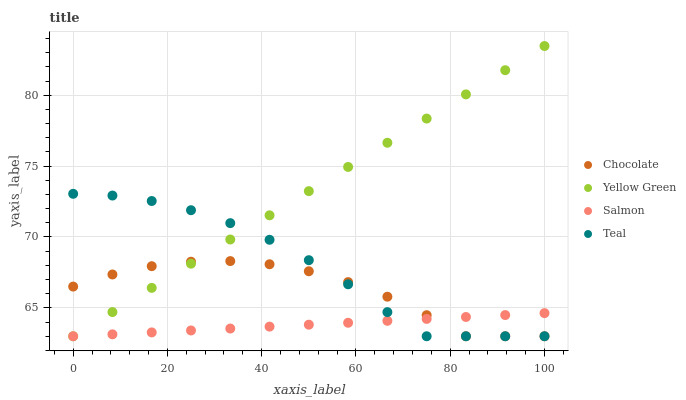Does Salmon have the minimum area under the curve?
Answer yes or no. Yes. Does Yellow Green have the maximum area under the curve?
Answer yes or no. Yes. Does Teal have the minimum area under the curve?
Answer yes or no. No. Does Teal have the maximum area under the curve?
Answer yes or no. No. Is Salmon the smoothest?
Answer yes or no. Yes. Is Chocolate the roughest?
Answer yes or no. Yes. Is Yellow Green the smoothest?
Answer yes or no. No. Is Yellow Green the roughest?
Answer yes or no. No. Does Salmon have the lowest value?
Answer yes or no. Yes. Does Yellow Green have the highest value?
Answer yes or no. Yes. Does Teal have the highest value?
Answer yes or no. No. Does Yellow Green intersect Teal?
Answer yes or no. Yes. Is Yellow Green less than Teal?
Answer yes or no. No. Is Yellow Green greater than Teal?
Answer yes or no. No. 